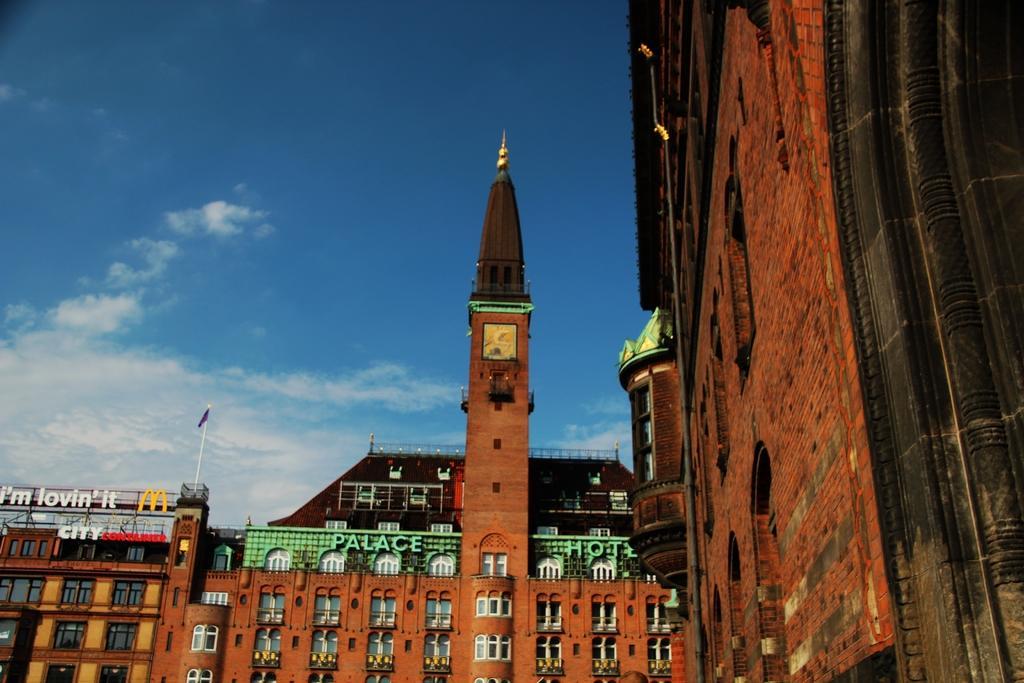How would you summarize this image in a sentence or two? In this image I can see few buildings which are black, brown and white in color. I can see a flag and the sky in the background. 